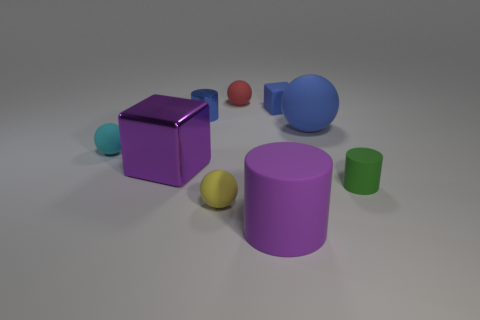Can you describe the colors and shapes of the objects in this image? Certainly. The image features a collection of geometric shapes with different colors and materials. From left to right, there's a small teal sphere, a purple metallic cube, a small yellow sphere, one large purple cylinder, a smaller green cylinder, and behind the purple cylinder, there's a large blue rubber cylinder with a small red ball behind it. 